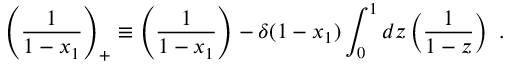<formula> <loc_0><loc_0><loc_500><loc_500>\left ( \frac { 1 } { 1 - x _ { 1 } } \right ) _ { + } \equiv \left ( \frac { 1 } { 1 - x _ { 1 } } \right ) - \delta ( 1 - x _ { 1 } ) \int _ { 0 } ^ { 1 } d z \left ( \frac { 1 } { 1 - z } \right ) \ .</formula> 